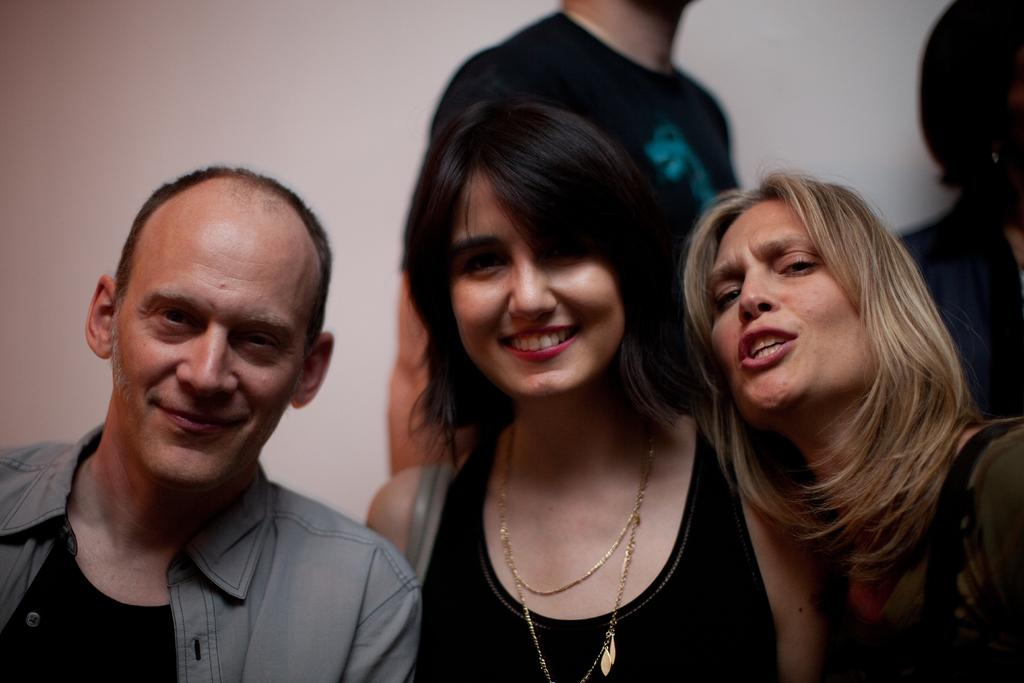How many people are present in the image? There are five people in the image, including two women, a man, and two other persons behind them. What is the color of the background in the image? The background of the image is white. How many cakes are being served by the girls in the image? There are no girls or cakes present in the image. 